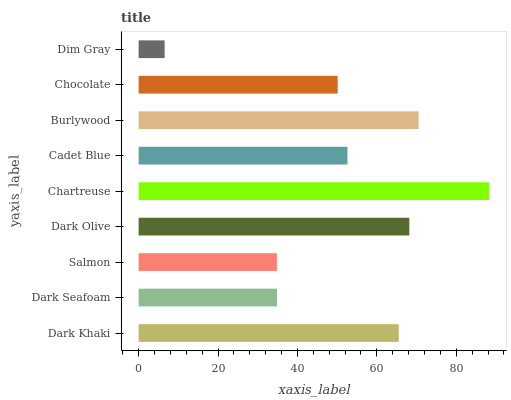Is Dim Gray the minimum?
Answer yes or no. Yes. Is Chartreuse the maximum?
Answer yes or no. Yes. Is Dark Seafoam the minimum?
Answer yes or no. No. Is Dark Seafoam the maximum?
Answer yes or no. No. Is Dark Khaki greater than Dark Seafoam?
Answer yes or no. Yes. Is Dark Seafoam less than Dark Khaki?
Answer yes or no. Yes. Is Dark Seafoam greater than Dark Khaki?
Answer yes or no. No. Is Dark Khaki less than Dark Seafoam?
Answer yes or no. No. Is Cadet Blue the high median?
Answer yes or no. Yes. Is Cadet Blue the low median?
Answer yes or no. Yes. Is Dark Olive the high median?
Answer yes or no. No. Is Dim Gray the low median?
Answer yes or no. No. 